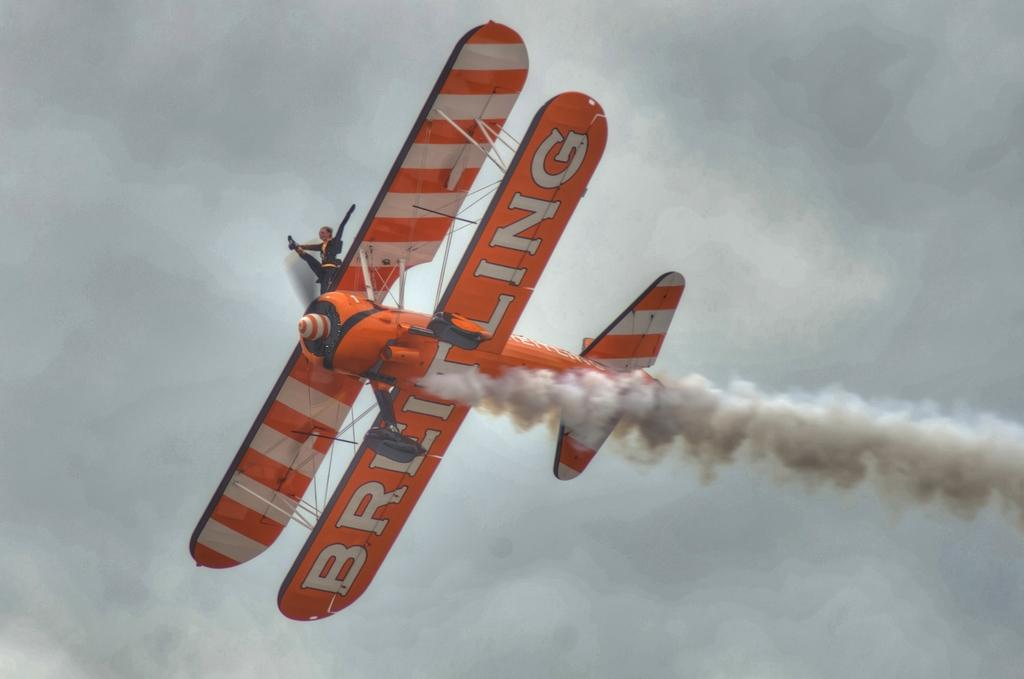<image>
Create a compact narrative representing the image presented. A stunt person stands atop a suspended biplane with Breitling written under its lower wing. 